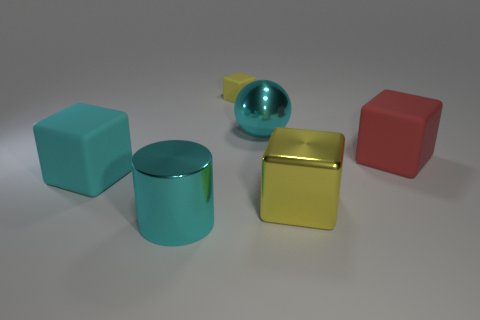Add 1 tiny objects. How many objects exist? 7 Subtract all balls. How many objects are left? 5 Subtract 0 green blocks. How many objects are left? 6 Subtract all tiny cyan shiny spheres. Subtract all red things. How many objects are left? 5 Add 2 cyan cubes. How many cyan cubes are left? 3 Add 4 tiny yellow things. How many tiny yellow things exist? 5 